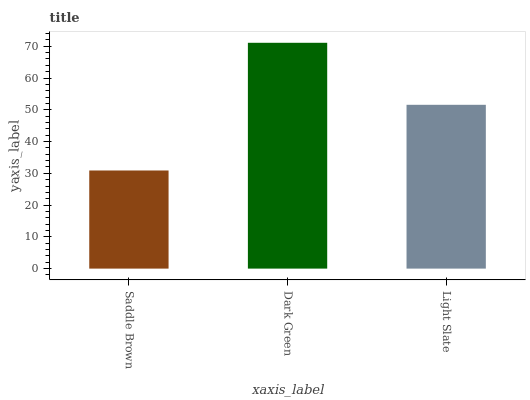Is Saddle Brown the minimum?
Answer yes or no. Yes. Is Dark Green the maximum?
Answer yes or no. Yes. Is Light Slate the minimum?
Answer yes or no. No. Is Light Slate the maximum?
Answer yes or no. No. Is Dark Green greater than Light Slate?
Answer yes or no. Yes. Is Light Slate less than Dark Green?
Answer yes or no. Yes. Is Light Slate greater than Dark Green?
Answer yes or no. No. Is Dark Green less than Light Slate?
Answer yes or no. No. Is Light Slate the high median?
Answer yes or no. Yes. Is Light Slate the low median?
Answer yes or no. Yes. Is Saddle Brown the high median?
Answer yes or no. No. Is Dark Green the low median?
Answer yes or no. No. 